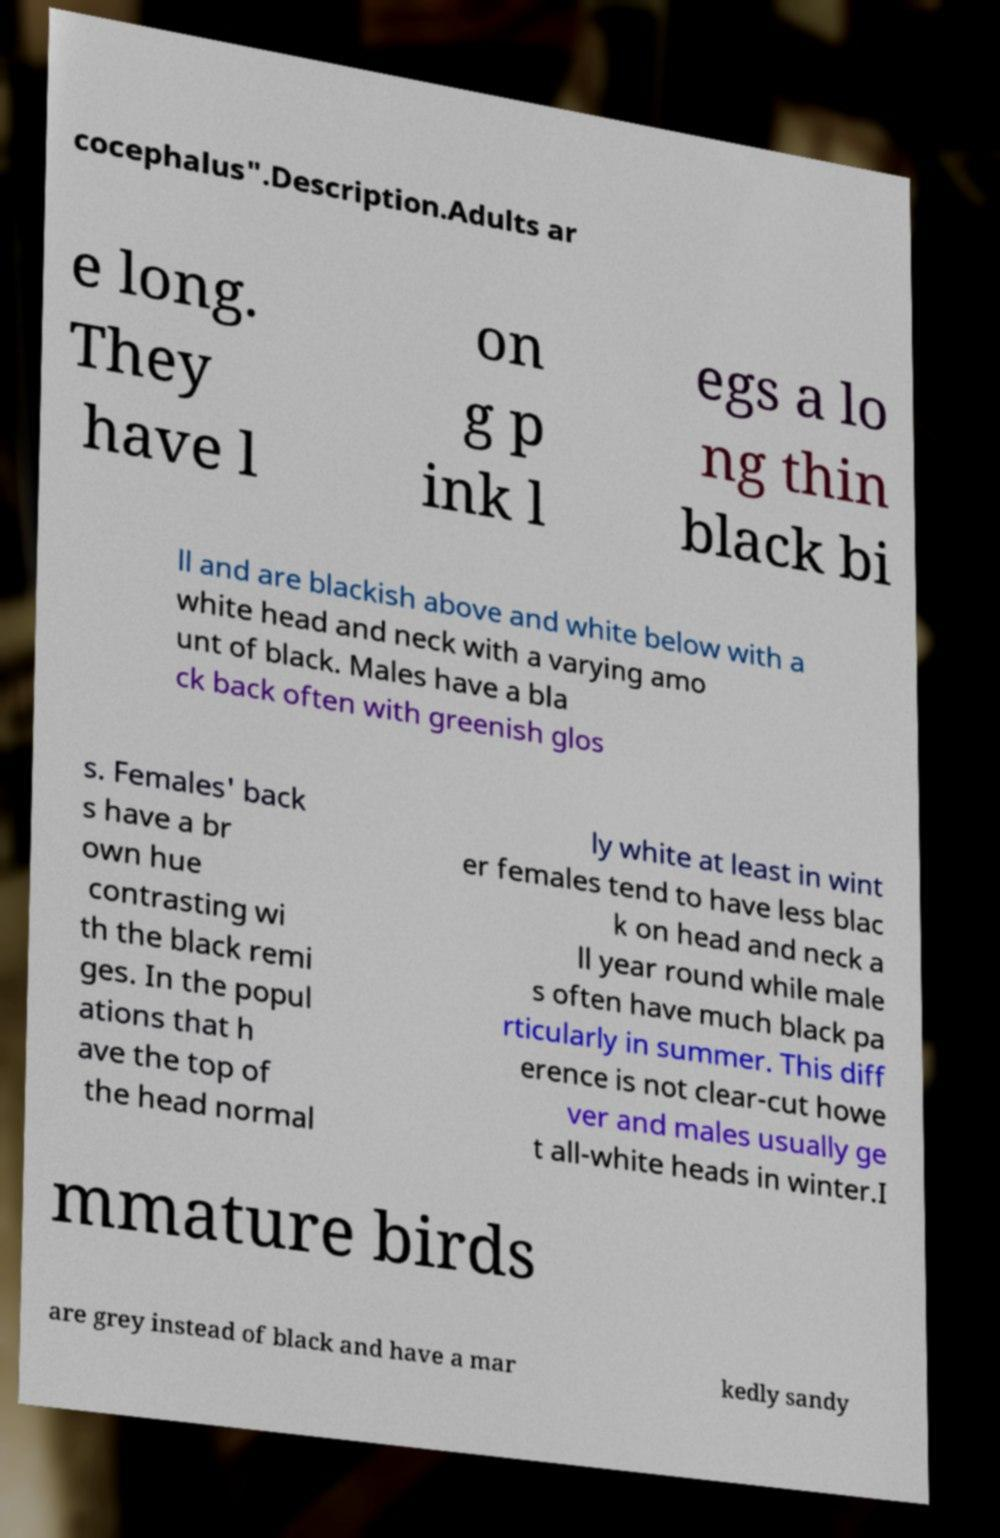Could you extract and type out the text from this image? cocephalus".Description.Adults ar e long. They have l on g p ink l egs a lo ng thin black bi ll and are blackish above and white below with a white head and neck with a varying amo unt of black. Males have a bla ck back often with greenish glos s. Females' back s have a br own hue contrasting wi th the black remi ges. In the popul ations that h ave the top of the head normal ly white at least in wint er females tend to have less blac k on head and neck a ll year round while male s often have much black pa rticularly in summer. This diff erence is not clear-cut howe ver and males usually ge t all-white heads in winter.I mmature birds are grey instead of black and have a mar kedly sandy 